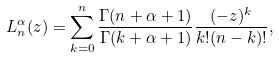<formula> <loc_0><loc_0><loc_500><loc_500>L _ { n } ^ { \alpha } ( z ) = \sum _ { k = 0 } ^ { n } \frac { \Gamma ( n + \alpha + 1 ) } { \Gamma ( k + \alpha + 1 ) } \frac { ( - z ) ^ { k } } { k ! ( n - k ) ! } ,</formula> 